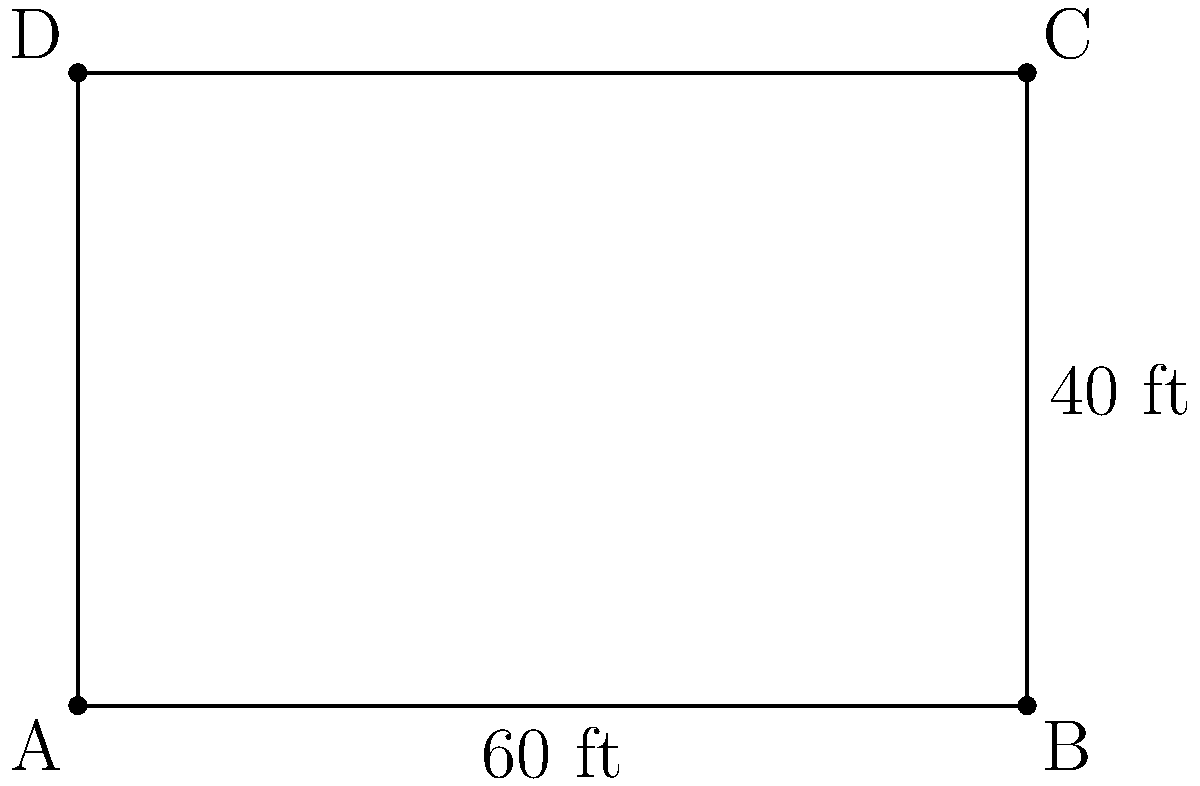A new school playground in South Los Angeles needs to be fenced for safety reasons. The rectangular playground measures 60 feet in length and 40 feet in width. If the fencing costs $12 per linear foot, what is the total cost to fence the entire playground? To solve this problem, we need to follow these steps:

1. Calculate the perimeter of the rectangular playground:
   - Perimeter = 2 × (length + width)
   - Perimeter = 2 × (60 ft + 40 ft)
   - Perimeter = 2 × 100 ft = 200 ft

2. Calculate the cost of fencing:
   - Cost per linear foot = $12
   - Total cost = Perimeter × Cost per linear foot
   - Total cost = 200 ft × $12/ft = $2,400

Therefore, the total cost to fence the entire playground is $2,400.
Answer: $2,400 